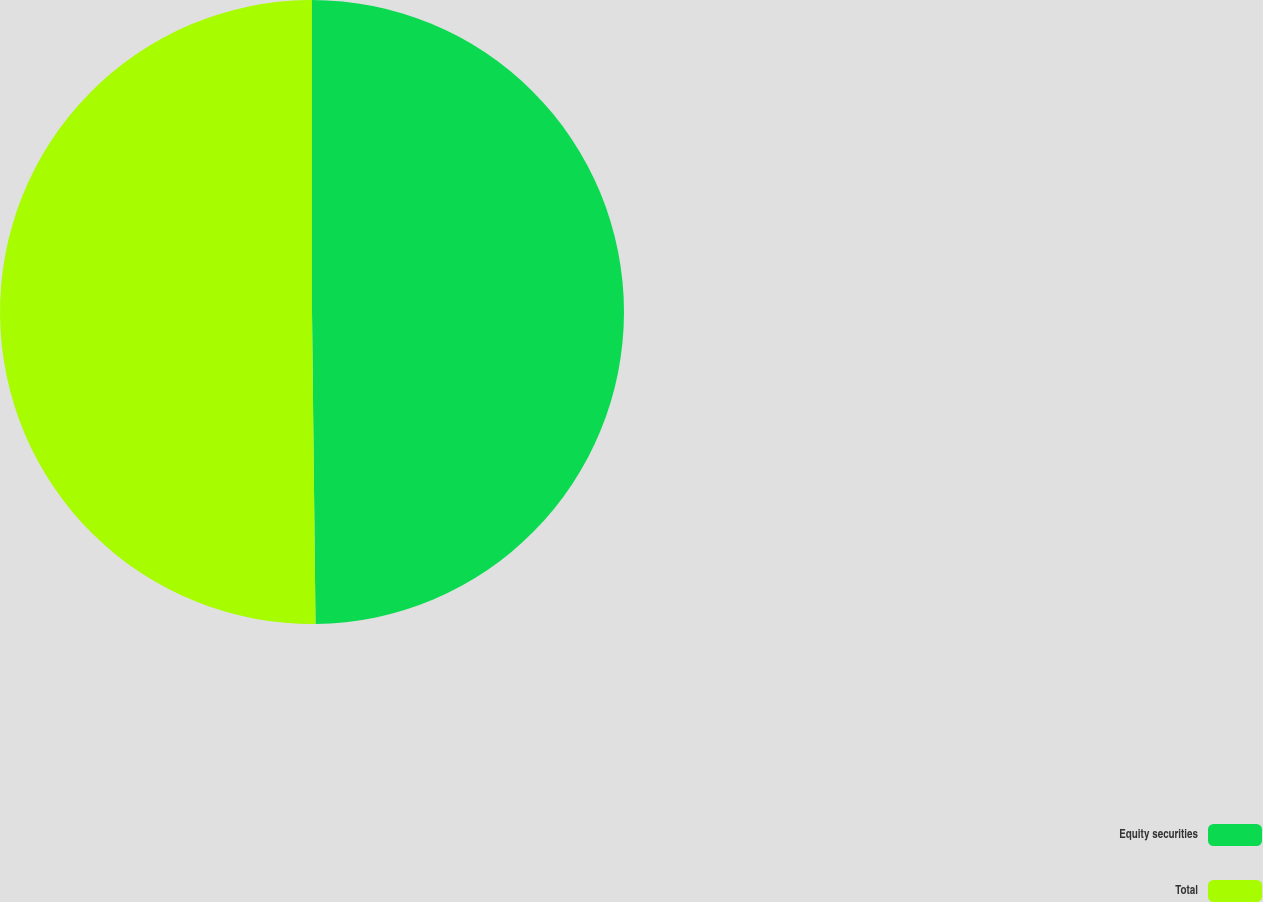<chart> <loc_0><loc_0><loc_500><loc_500><pie_chart><fcel>Equity securities<fcel>Total<nl><fcel>49.82%<fcel>50.18%<nl></chart> 